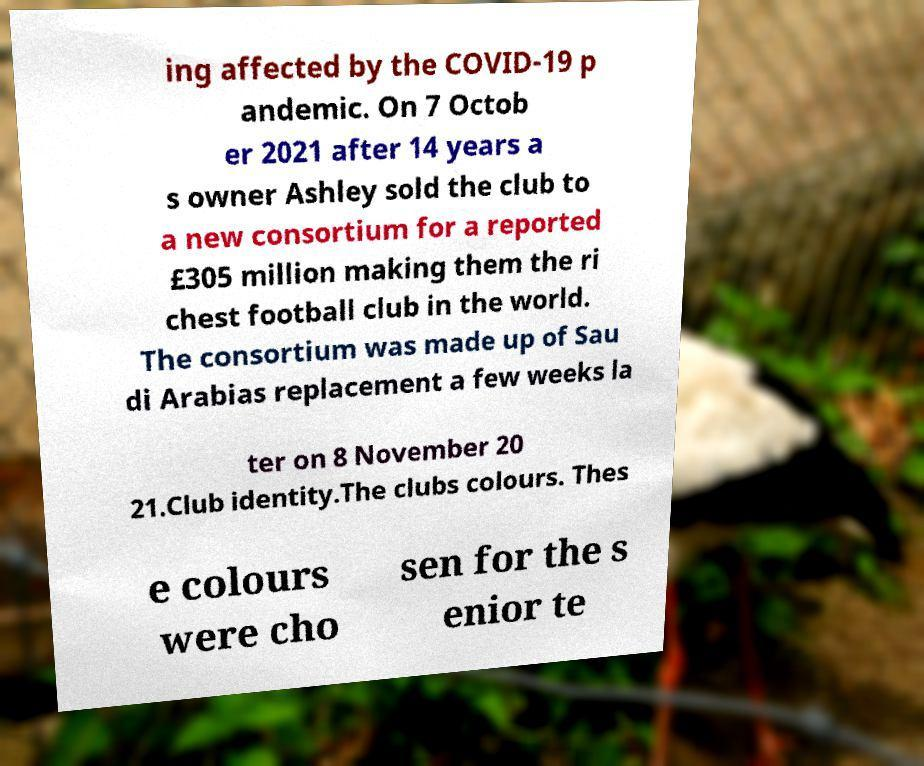For documentation purposes, I need the text within this image transcribed. Could you provide that? ing affected by the COVID-19 p andemic. On 7 Octob er 2021 after 14 years a s owner Ashley sold the club to a new consortium for a reported £305 million making them the ri chest football club in the world. The consortium was made up of Sau di Arabias replacement a few weeks la ter on 8 November 20 21.Club identity.The clubs colours. Thes e colours were cho sen for the s enior te 